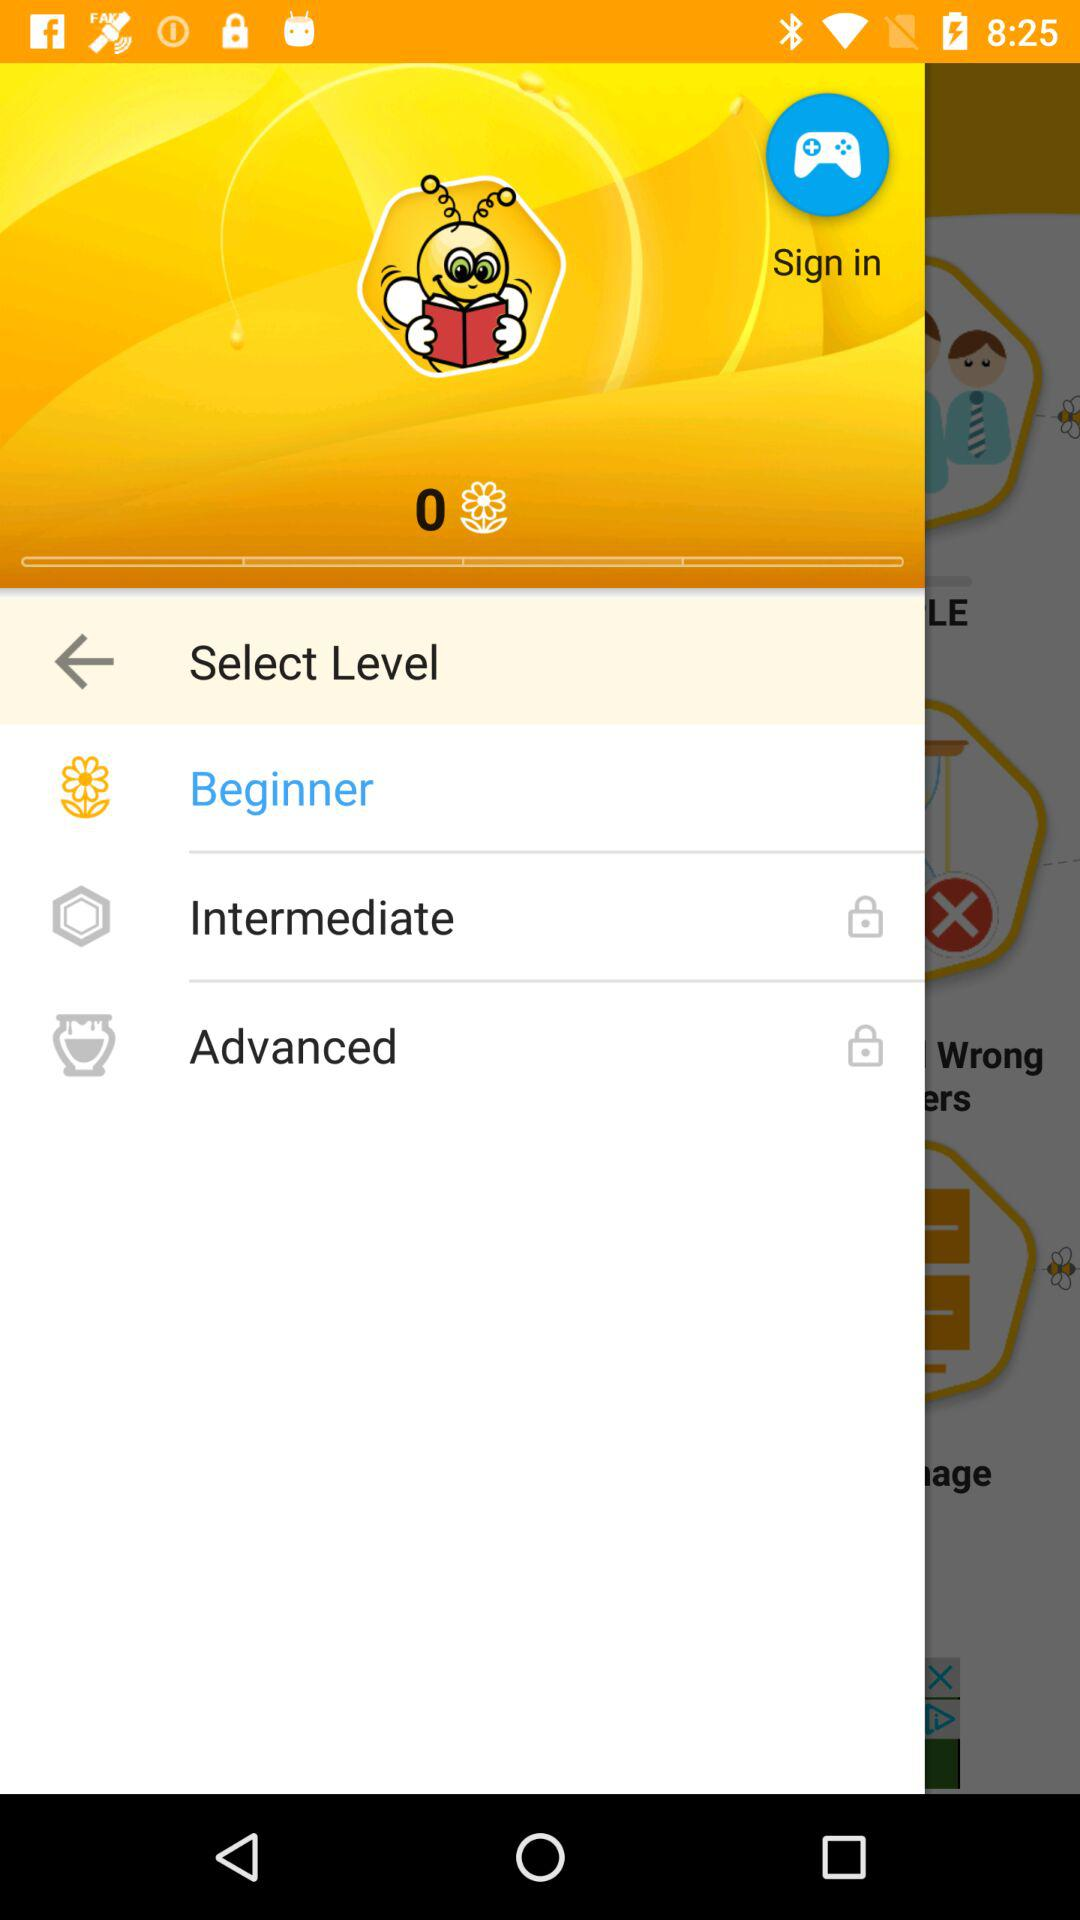How many levels are there in total?
Answer the question using a single word or phrase. 3 